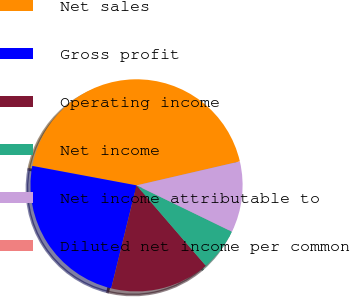<chart> <loc_0><loc_0><loc_500><loc_500><pie_chart><fcel>Net sales<fcel>Gross profit<fcel>Operating income<fcel>Net income<fcel>Net income attributable to<fcel>Diluted net income per common<nl><fcel>43.44%<fcel>24.1%<fcel>15.16%<fcel>6.48%<fcel>10.82%<fcel>0.0%<nl></chart> 